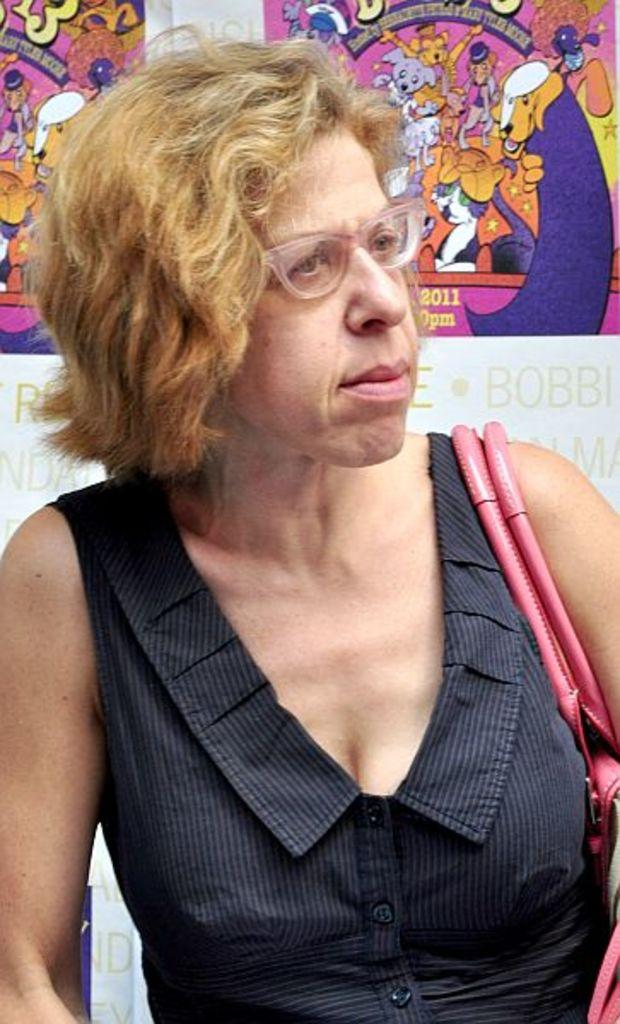Who is present in the image? There is a woman in the image. What is the woman wearing? The woman is wearing a black dress and spectacles. What is the woman carrying? The woman is carrying a bag. How would you describe the background of the image? The background of the image has a cartoon theme. Can you see any visible veins on the woman's hand in the image? There is no information about the woman's hand or any visible veins in the image. 